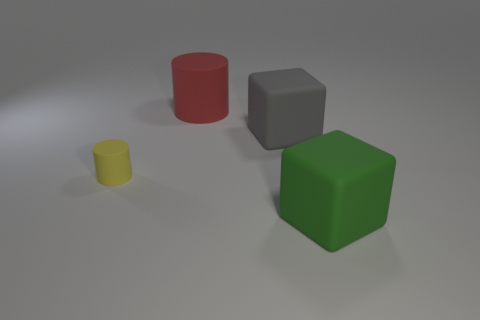What lighting conditions are present in this scene? The scene is lit with diffuse lighting, creating soft shadows. It seems there is a single light source slightly off to the upper left, based on the directions of the shadows of the objects. 